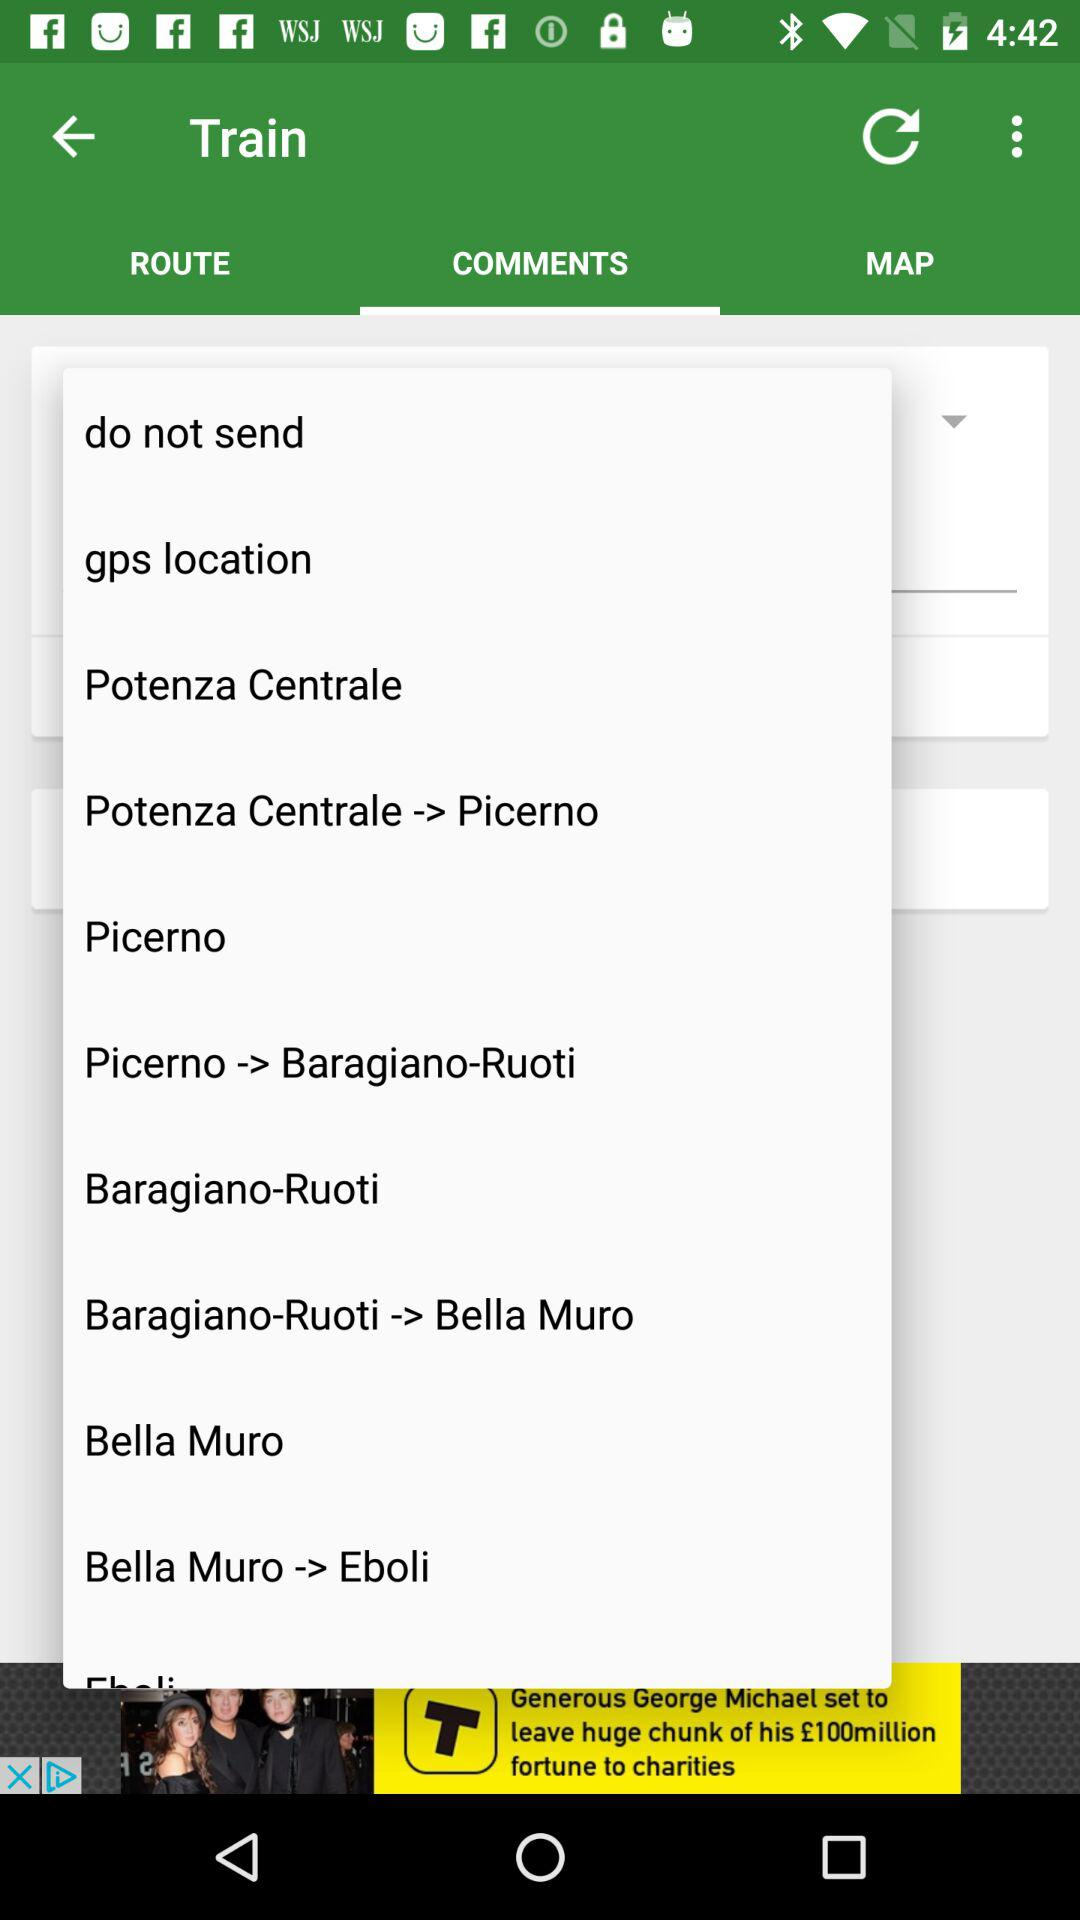What tab is selected? The selected tab is "COMMENTS". 